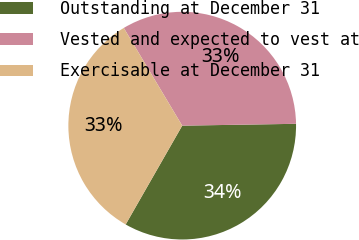<chart> <loc_0><loc_0><loc_500><loc_500><pie_chart><fcel>Outstanding at December 31<fcel>Vested and expected to vest at<fcel>Exercisable at December 31<nl><fcel>33.53%<fcel>33.32%<fcel>33.15%<nl></chart> 